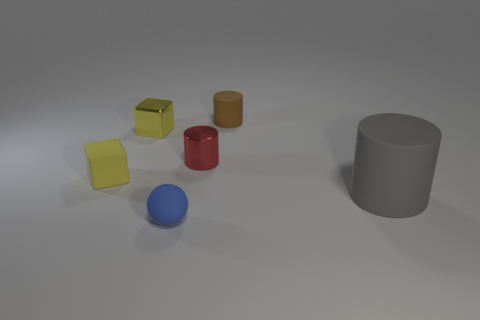Subtract all tiny cylinders. How many cylinders are left? 1 Add 2 matte balls. How many objects exist? 8 Subtract all brown cylinders. How many cylinders are left? 2 Subtract all balls. How many objects are left? 5 Add 4 gray objects. How many gray objects are left? 5 Add 2 gray things. How many gray things exist? 3 Subtract 0 purple balls. How many objects are left? 6 Subtract all gray spheres. Subtract all brown blocks. How many spheres are left? 1 Subtract all yellow metal things. Subtract all large gray cylinders. How many objects are left? 4 